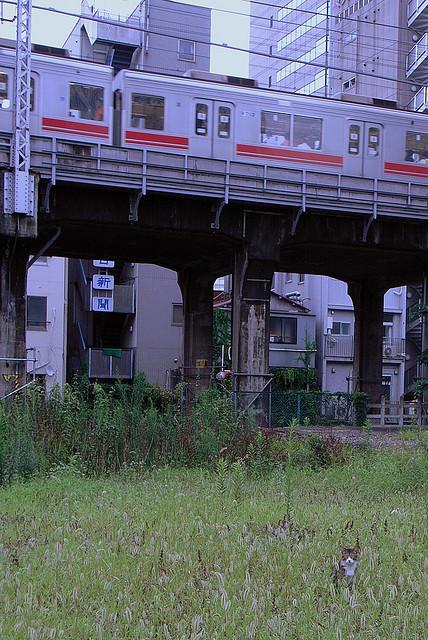What is on the rails above the grass?
Concise answer only. Train. Is this a bridge?
Give a very brief answer. Yes. Is there an animal in the grass?
Keep it brief. Yes. 